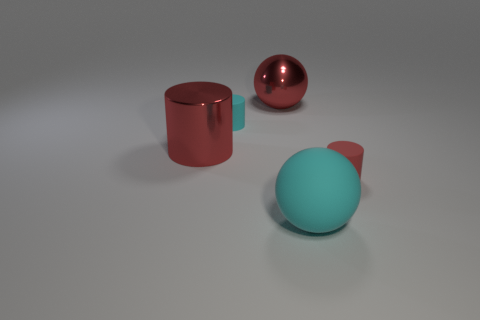Subtract all matte cylinders. How many cylinders are left? 1 Subtract all cyan blocks. How many red cylinders are left? 2 Add 3 cyan rubber balls. How many objects exist? 8 Subtract all spheres. How many objects are left? 3 Subtract all yellow cylinders. Subtract all green spheres. How many cylinders are left? 3 Add 1 big objects. How many big objects are left? 4 Add 1 green cylinders. How many green cylinders exist? 1 Subtract 0 gray cylinders. How many objects are left? 5 Subtract all big cyan rubber things. Subtract all shiny blocks. How many objects are left? 4 